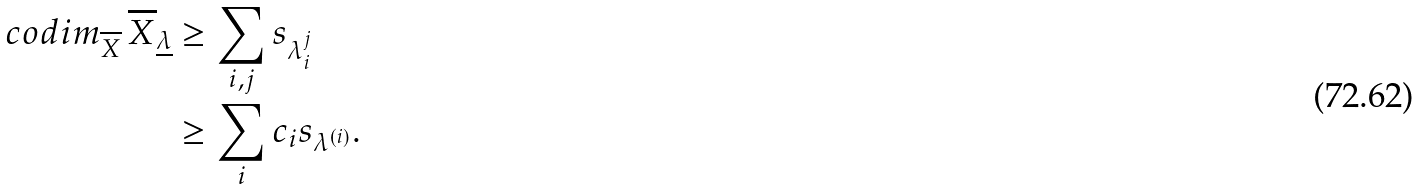Convert formula to latex. <formula><loc_0><loc_0><loc_500><loc_500>c o d i m _ { \overline { X } } \, \overline { X } _ { \underline { \lambda } } & \geq \sum _ { i , j } s _ { \lambda _ { i } ^ { j } } \\ & \geq \sum _ { i } c _ { i } s _ { \lambda ^ { ( i ) } } .</formula> 